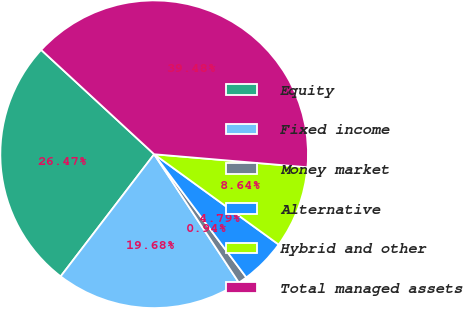Convert chart. <chart><loc_0><loc_0><loc_500><loc_500><pie_chart><fcel>Equity<fcel>Fixed income<fcel>Money market<fcel>Alternative<fcel>Hybrid and other<fcel>Total managed assets<nl><fcel>26.47%<fcel>19.68%<fcel>0.94%<fcel>4.79%<fcel>8.64%<fcel>39.48%<nl></chart> 